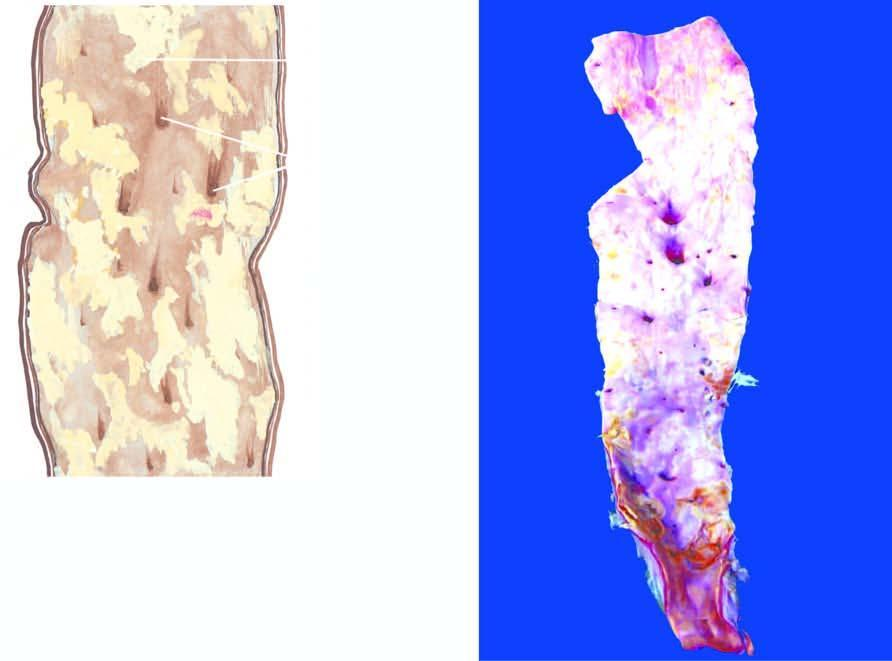re right sideshows smoking-related neoplastic diseases while left side indicates non-neoplastic diseases associated with smoking, narrowed by the atherosclerotic process?
Answer the question using a single word or phrase. No 